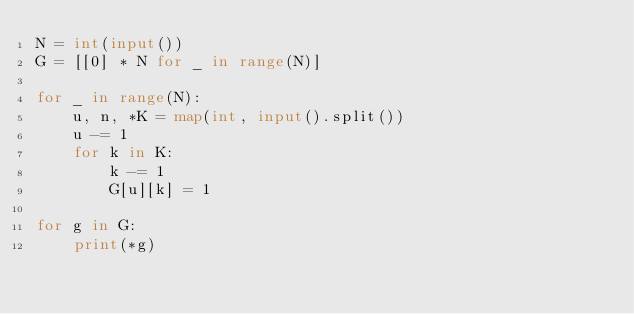<code> <loc_0><loc_0><loc_500><loc_500><_Python_>N = int(input())
G = [[0] * N for _ in range(N)]

for _ in range(N):
    u, n, *K = map(int, input().split())
    u -= 1
    for k in K:
        k -= 1
        G[u][k] = 1

for g in G:
    print(*g)

</code> 